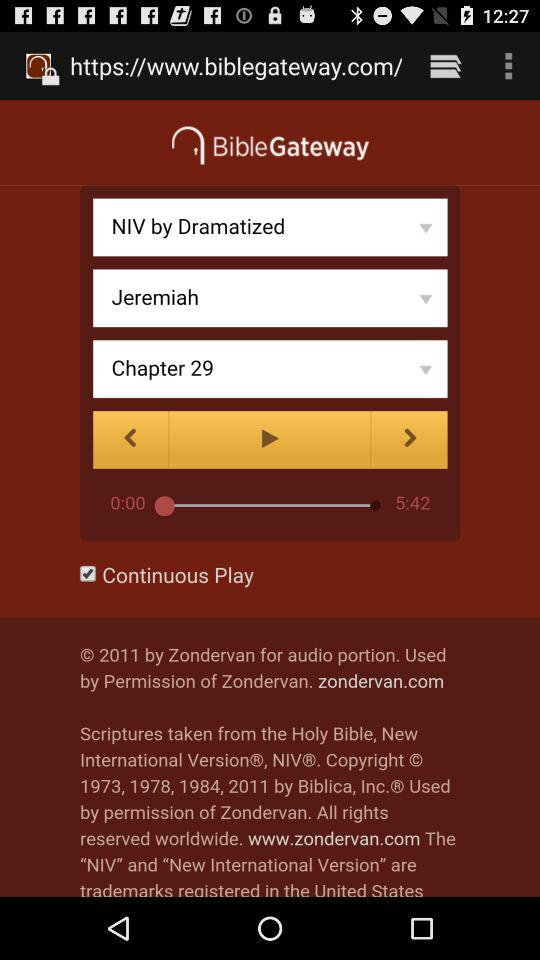Which chapter is selected? The selected chapter is 29. 